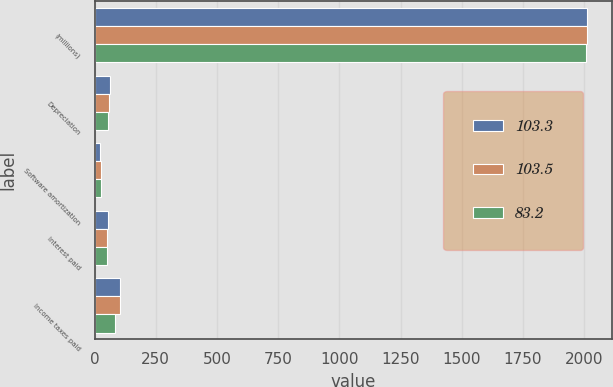Convert chart to OTSL. <chart><loc_0><loc_0><loc_500><loc_500><stacked_bar_chart><ecel><fcel>(millions)<fcel>Depreciation<fcel>Software amortization<fcel>Interest paid<fcel>Income taxes paid<nl><fcel>103.3<fcel>2012<fcel>63.6<fcel>23.7<fcel>54.7<fcel>103.3<nl><fcel>103.5<fcel>2011<fcel>58.1<fcel>24.4<fcel>49.6<fcel>103.5<nl><fcel>83.2<fcel>2010<fcel>54<fcel>25<fcel>49.3<fcel>83.2<nl></chart> 